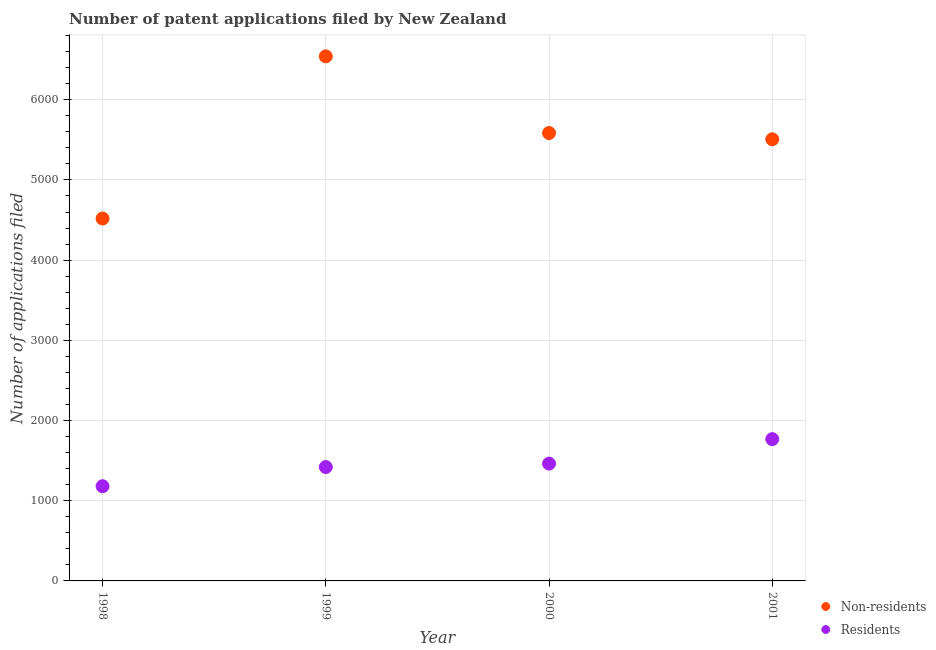Is the number of dotlines equal to the number of legend labels?
Your answer should be compact. Yes. What is the number of patent applications by non residents in 1999?
Keep it short and to the point. 6541. Across all years, what is the maximum number of patent applications by residents?
Your response must be concise. 1768. Across all years, what is the minimum number of patent applications by non residents?
Offer a terse response. 4519. In which year was the number of patent applications by residents maximum?
Ensure brevity in your answer.  2001. In which year was the number of patent applications by residents minimum?
Your response must be concise. 1998. What is the total number of patent applications by residents in the graph?
Keep it short and to the point. 5832. What is the difference between the number of patent applications by residents in 1998 and that in 1999?
Keep it short and to the point. -239. What is the difference between the number of patent applications by non residents in 1999 and the number of patent applications by residents in 1998?
Provide a succinct answer. 5360. What is the average number of patent applications by residents per year?
Give a very brief answer. 1458. In the year 1999, what is the difference between the number of patent applications by non residents and number of patent applications by residents?
Provide a short and direct response. 5121. What is the ratio of the number of patent applications by non residents in 1998 to that in 2001?
Your answer should be very brief. 0.82. What is the difference between the highest and the second highest number of patent applications by residents?
Your response must be concise. 305. What is the difference between the highest and the lowest number of patent applications by non residents?
Offer a very short reply. 2022. Is the sum of the number of patent applications by residents in 1998 and 2001 greater than the maximum number of patent applications by non residents across all years?
Provide a succinct answer. No. Does the number of patent applications by residents monotonically increase over the years?
Your answer should be compact. Yes. Is the number of patent applications by non residents strictly less than the number of patent applications by residents over the years?
Your answer should be very brief. No. Are the values on the major ticks of Y-axis written in scientific E-notation?
Offer a terse response. No. Does the graph contain grids?
Your answer should be very brief. Yes. Where does the legend appear in the graph?
Your response must be concise. Bottom right. How are the legend labels stacked?
Offer a terse response. Vertical. What is the title of the graph?
Your answer should be compact. Number of patent applications filed by New Zealand. Does "Females" appear as one of the legend labels in the graph?
Keep it short and to the point. No. What is the label or title of the X-axis?
Provide a succinct answer. Year. What is the label or title of the Y-axis?
Keep it short and to the point. Number of applications filed. What is the Number of applications filed of Non-residents in 1998?
Ensure brevity in your answer.  4519. What is the Number of applications filed of Residents in 1998?
Provide a short and direct response. 1181. What is the Number of applications filed in Non-residents in 1999?
Keep it short and to the point. 6541. What is the Number of applications filed of Residents in 1999?
Provide a short and direct response. 1420. What is the Number of applications filed in Non-residents in 2000?
Your answer should be very brief. 5585. What is the Number of applications filed of Residents in 2000?
Your answer should be very brief. 1463. What is the Number of applications filed in Non-residents in 2001?
Your answer should be compact. 5507. What is the Number of applications filed in Residents in 2001?
Provide a short and direct response. 1768. Across all years, what is the maximum Number of applications filed in Non-residents?
Offer a terse response. 6541. Across all years, what is the maximum Number of applications filed of Residents?
Offer a terse response. 1768. Across all years, what is the minimum Number of applications filed of Non-residents?
Your answer should be very brief. 4519. Across all years, what is the minimum Number of applications filed of Residents?
Ensure brevity in your answer.  1181. What is the total Number of applications filed in Non-residents in the graph?
Give a very brief answer. 2.22e+04. What is the total Number of applications filed in Residents in the graph?
Offer a terse response. 5832. What is the difference between the Number of applications filed of Non-residents in 1998 and that in 1999?
Offer a terse response. -2022. What is the difference between the Number of applications filed in Residents in 1998 and that in 1999?
Make the answer very short. -239. What is the difference between the Number of applications filed in Non-residents in 1998 and that in 2000?
Your answer should be compact. -1066. What is the difference between the Number of applications filed in Residents in 1998 and that in 2000?
Offer a terse response. -282. What is the difference between the Number of applications filed in Non-residents in 1998 and that in 2001?
Provide a short and direct response. -988. What is the difference between the Number of applications filed of Residents in 1998 and that in 2001?
Offer a very short reply. -587. What is the difference between the Number of applications filed in Non-residents in 1999 and that in 2000?
Offer a very short reply. 956. What is the difference between the Number of applications filed in Residents in 1999 and that in 2000?
Keep it short and to the point. -43. What is the difference between the Number of applications filed of Non-residents in 1999 and that in 2001?
Your answer should be compact. 1034. What is the difference between the Number of applications filed in Residents in 1999 and that in 2001?
Make the answer very short. -348. What is the difference between the Number of applications filed of Residents in 2000 and that in 2001?
Your response must be concise. -305. What is the difference between the Number of applications filed of Non-residents in 1998 and the Number of applications filed of Residents in 1999?
Your answer should be compact. 3099. What is the difference between the Number of applications filed of Non-residents in 1998 and the Number of applications filed of Residents in 2000?
Make the answer very short. 3056. What is the difference between the Number of applications filed of Non-residents in 1998 and the Number of applications filed of Residents in 2001?
Offer a terse response. 2751. What is the difference between the Number of applications filed of Non-residents in 1999 and the Number of applications filed of Residents in 2000?
Give a very brief answer. 5078. What is the difference between the Number of applications filed in Non-residents in 1999 and the Number of applications filed in Residents in 2001?
Ensure brevity in your answer.  4773. What is the difference between the Number of applications filed of Non-residents in 2000 and the Number of applications filed of Residents in 2001?
Give a very brief answer. 3817. What is the average Number of applications filed in Non-residents per year?
Your answer should be very brief. 5538. What is the average Number of applications filed in Residents per year?
Provide a short and direct response. 1458. In the year 1998, what is the difference between the Number of applications filed of Non-residents and Number of applications filed of Residents?
Make the answer very short. 3338. In the year 1999, what is the difference between the Number of applications filed of Non-residents and Number of applications filed of Residents?
Ensure brevity in your answer.  5121. In the year 2000, what is the difference between the Number of applications filed in Non-residents and Number of applications filed in Residents?
Your answer should be compact. 4122. In the year 2001, what is the difference between the Number of applications filed in Non-residents and Number of applications filed in Residents?
Provide a short and direct response. 3739. What is the ratio of the Number of applications filed in Non-residents in 1998 to that in 1999?
Provide a succinct answer. 0.69. What is the ratio of the Number of applications filed in Residents in 1998 to that in 1999?
Offer a very short reply. 0.83. What is the ratio of the Number of applications filed of Non-residents in 1998 to that in 2000?
Provide a short and direct response. 0.81. What is the ratio of the Number of applications filed of Residents in 1998 to that in 2000?
Make the answer very short. 0.81. What is the ratio of the Number of applications filed in Non-residents in 1998 to that in 2001?
Give a very brief answer. 0.82. What is the ratio of the Number of applications filed in Residents in 1998 to that in 2001?
Provide a short and direct response. 0.67. What is the ratio of the Number of applications filed of Non-residents in 1999 to that in 2000?
Give a very brief answer. 1.17. What is the ratio of the Number of applications filed of Residents in 1999 to that in 2000?
Make the answer very short. 0.97. What is the ratio of the Number of applications filed of Non-residents in 1999 to that in 2001?
Give a very brief answer. 1.19. What is the ratio of the Number of applications filed of Residents in 1999 to that in 2001?
Your response must be concise. 0.8. What is the ratio of the Number of applications filed of Non-residents in 2000 to that in 2001?
Your response must be concise. 1.01. What is the ratio of the Number of applications filed in Residents in 2000 to that in 2001?
Give a very brief answer. 0.83. What is the difference between the highest and the second highest Number of applications filed of Non-residents?
Provide a short and direct response. 956. What is the difference between the highest and the second highest Number of applications filed of Residents?
Your answer should be very brief. 305. What is the difference between the highest and the lowest Number of applications filed in Non-residents?
Your answer should be very brief. 2022. What is the difference between the highest and the lowest Number of applications filed of Residents?
Your answer should be very brief. 587. 